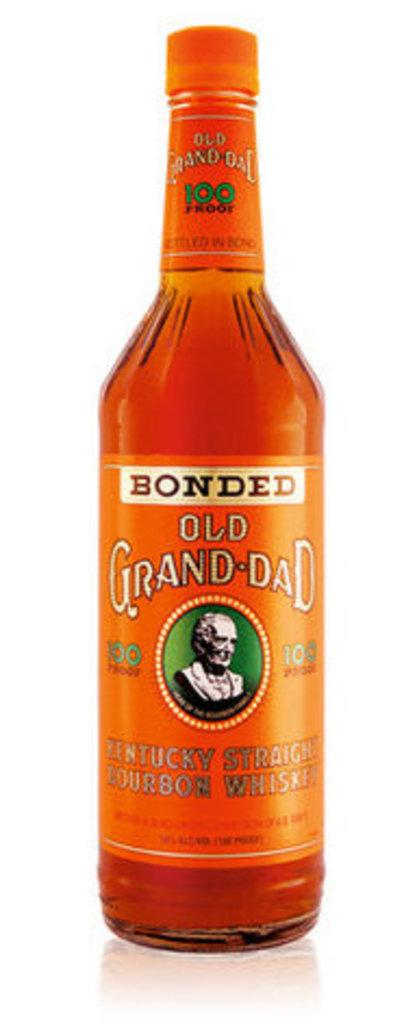<image>
Render a clear and concise summary of the photo. a bottle of Old grandad whiskey on a table 